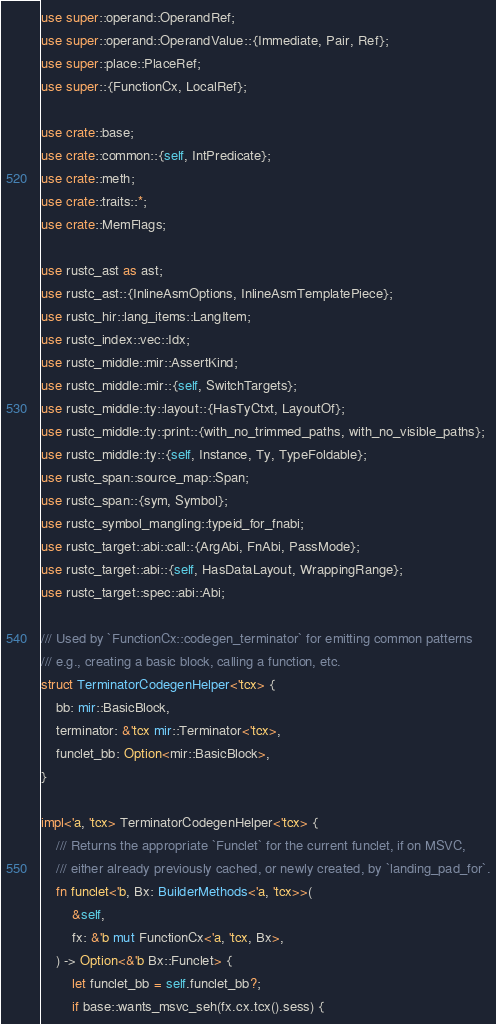<code> <loc_0><loc_0><loc_500><loc_500><_Rust_>use super::operand::OperandRef;
use super::operand::OperandValue::{Immediate, Pair, Ref};
use super::place::PlaceRef;
use super::{FunctionCx, LocalRef};

use crate::base;
use crate::common::{self, IntPredicate};
use crate::meth;
use crate::traits::*;
use crate::MemFlags;

use rustc_ast as ast;
use rustc_ast::{InlineAsmOptions, InlineAsmTemplatePiece};
use rustc_hir::lang_items::LangItem;
use rustc_index::vec::Idx;
use rustc_middle::mir::AssertKind;
use rustc_middle::mir::{self, SwitchTargets};
use rustc_middle::ty::layout::{HasTyCtxt, LayoutOf};
use rustc_middle::ty::print::{with_no_trimmed_paths, with_no_visible_paths};
use rustc_middle::ty::{self, Instance, Ty, TypeFoldable};
use rustc_span::source_map::Span;
use rustc_span::{sym, Symbol};
use rustc_symbol_mangling::typeid_for_fnabi;
use rustc_target::abi::call::{ArgAbi, FnAbi, PassMode};
use rustc_target::abi::{self, HasDataLayout, WrappingRange};
use rustc_target::spec::abi::Abi;

/// Used by `FunctionCx::codegen_terminator` for emitting common patterns
/// e.g., creating a basic block, calling a function, etc.
struct TerminatorCodegenHelper<'tcx> {
    bb: mir::BasicBlock,
    terminator: &'tcx mir::Terminator<'tcx>,
    funclet_bb: Option<mir::BasicBlock>,
}

impl<'a, 'tcx> TerminatorCodegenHelper<'tcx> {
    /// Returns the appropriate `Funclet` for the current funclet, if on MSVC,
    /// either already previously cached, or newly created, by `landing_pad_for`.
    fn funclet<'b, Bx: BuilderMethods<'a, 'tcx>>(
        &self,
        fx: &'b mut FunctionCx<'a, 'tcx, Bx>,
    ) -> Option<&'b Bx::Funclet> {
        let funclet_bb = self.funclet_bb?;
        if base::wants_msvc_seh(fx.cx.tcx().sess) {</code> 